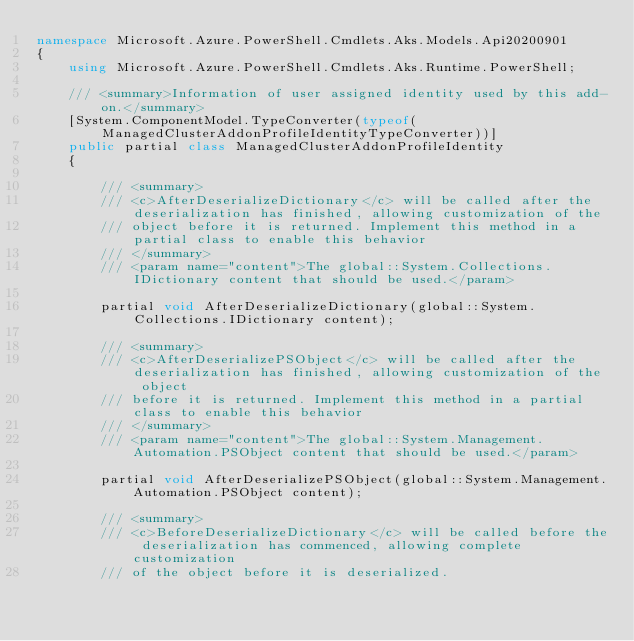<code> <loc_0><loc_0><loc_500><loc_500><_C#_>namespace Microsoft.Azure.PowerShell.Cmdlets.Aks.Models.Api20200901
{
    using Microsoft.Azure.PowerShell.Cmdlets.Aks.Runtime.PowerShell;

    /// <summary>Information of user assigned identity used by this add-on.</summary>
    [System.ComponentModel.TypeConverter(typeof(ManagedClusterAddonProfileIdentityTypeConverter))]
    public partial class ManagedClusterAddonProfileIdentity
    {

        /// <summary>
        /// <c>AfterDeserializeDictionary</c> will be called after the deserialization has finished, allowing customization of the
        /// object before it is returned. Implement this method in a partial class to enable this behavior
        /// </summary>
        /// <param name="content">The global::System.Collections.IDictionary content that should be used.</param>

        partial void AfterDeserializeDictionary(global::System.Collections.IDictionary content);

        /// <summary>
        /// <c>AfterDeserializePSObject</c> will be called after the deserialization has finished, allowing customization of the object
        /// before it is returned. Implement this method in a partial class to enable this behavior
        /// </summary>
        /// <param name="content">The global::System.Management.Automation.PSObject content that should be used.</param>

        partial void AfterDeserializePSObject(global::System.Management.Automation.PSObject content);

        /// <summary>
        /// <c>BeforeDeserializeDictionary</c> will be called before the deserialization has commenced, allowing complete customization
        /// of the object before it is deserialized.</code> 